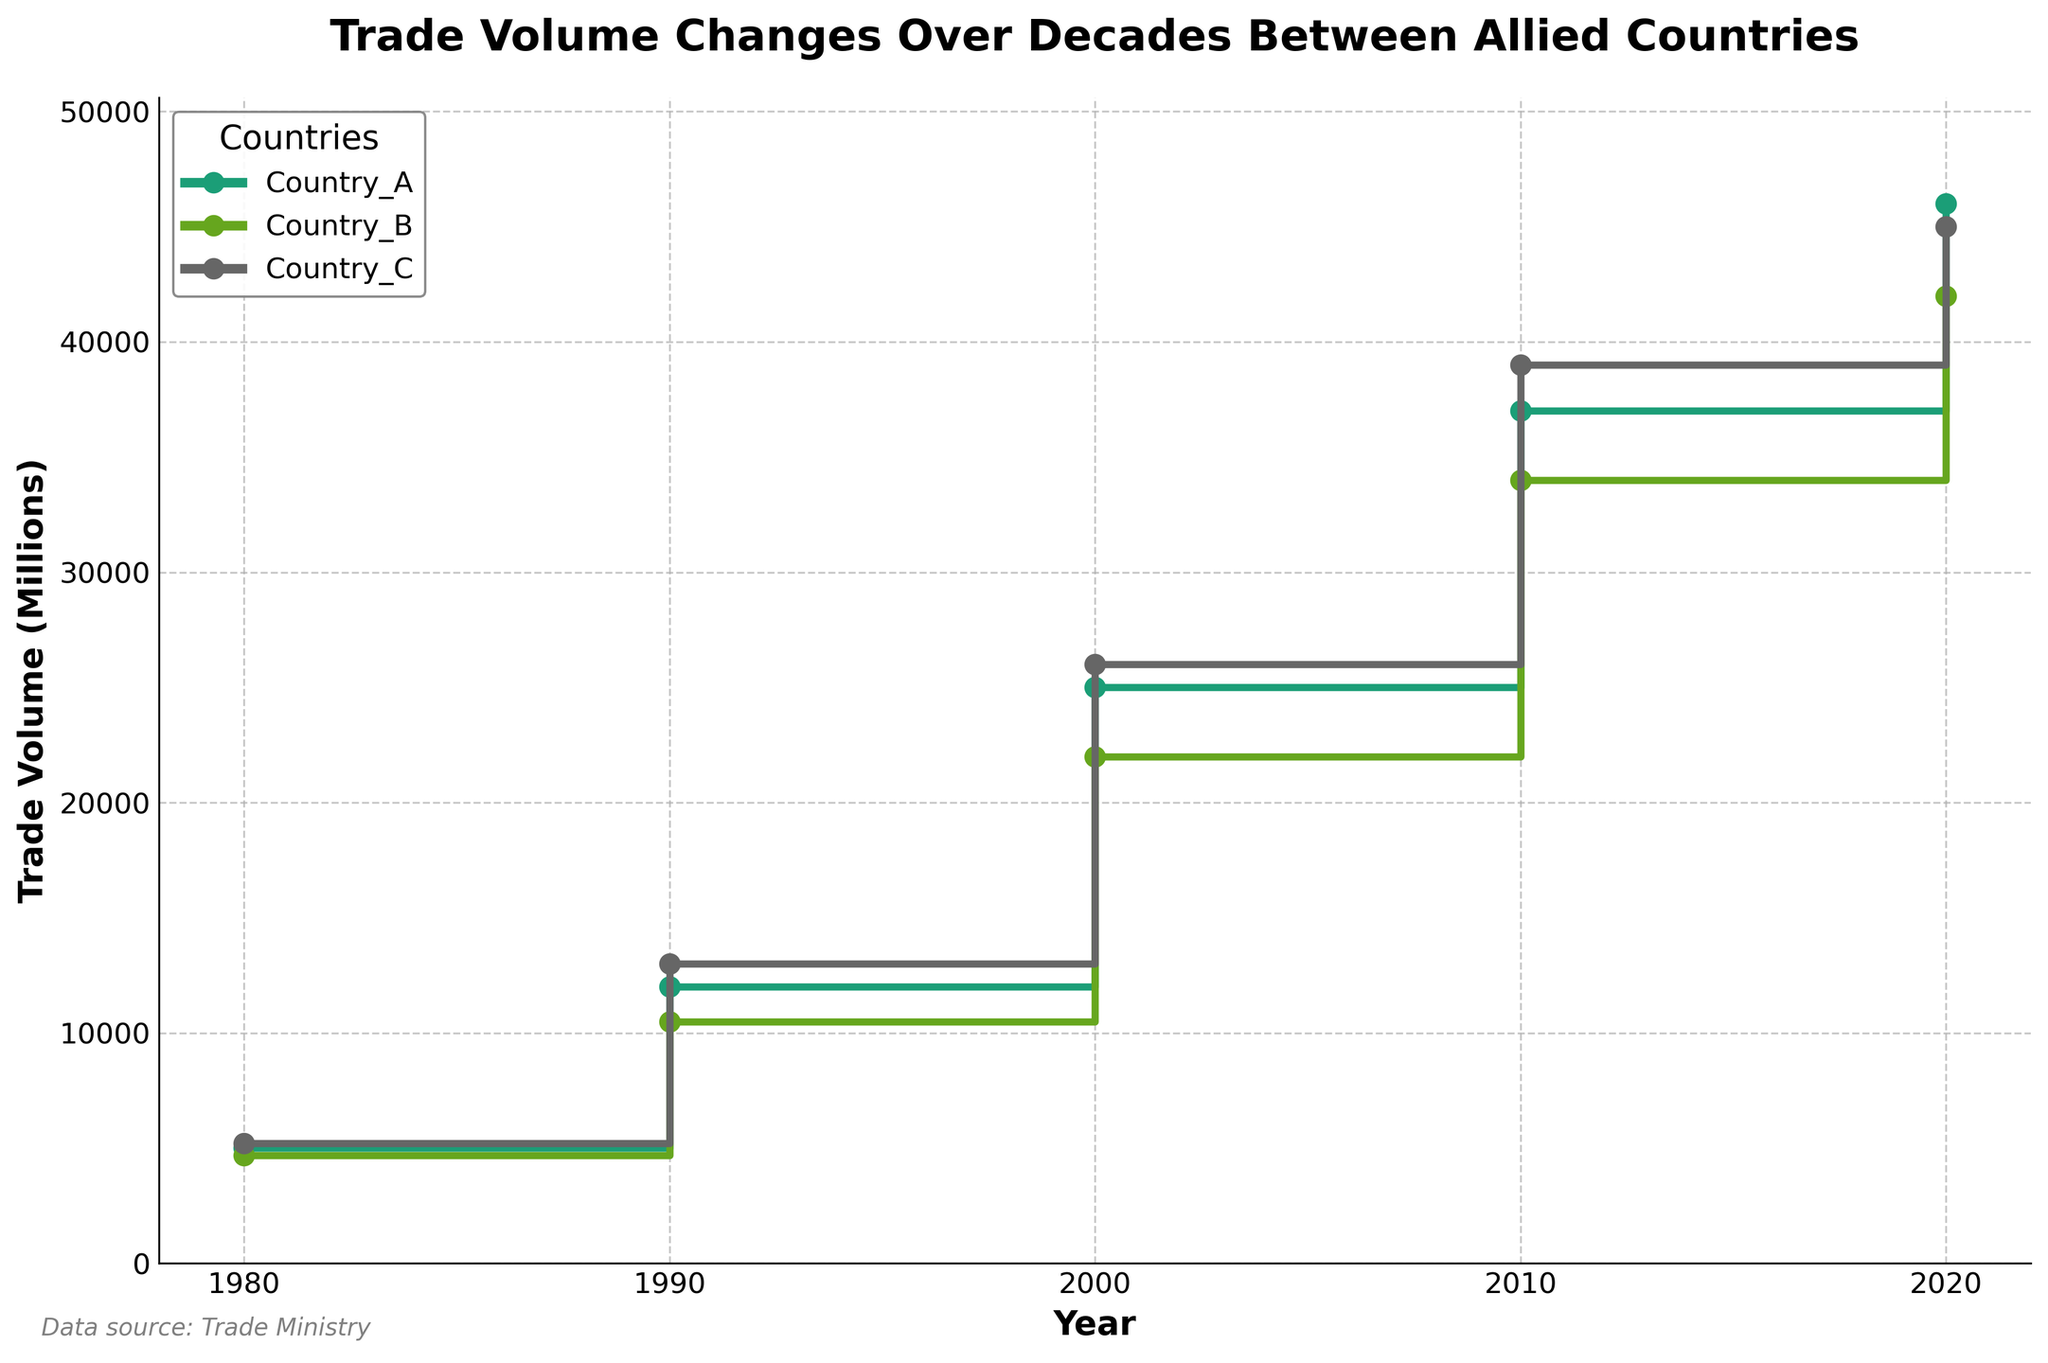What is the title of the figure? The title is the text prominently displayed at the top of the figure. It summarizes the plot's overall theme. In this case, it reads "Trade Volume Changes Over Decades Between Allied Countries."
Answer: Trade Volume Changes Over Decades Between Allied Countries Which country had the highest trade volume in 2020? To determine this, compare the trade volume for each country in the year 2020. Poland has a trade volume of 46,000, Germany 42,000, and France 45,000. The highest trade volume among these is Poland's.
Answer: Poland How many distinct years are shown in the figure? The figure shows data on a horizontal axis with markers for each distinct year. The years labeled are 1980, 1990, 2000, 2010, and 2020. Counting these gives us 5 distinct years.
Answer: 5 Which country showed the largest increase in trade volume from 1980 to 1990? For each country, calculate the difference in trade volume between 1980 and 1990. Poland: 12,000 - 5,000 = 7,000, Germany: 10,500 - 4,700 = 5,800, France: 13,000 - 5,200 = 7,800. France showed the largest increase.
Answer: France What's the average trade volume for Germany across all years? To find the average, sum up Germany's trade volumes for all years and divide by the number of years. (4,700 + 10,500 + 22,000 + 34,000 + 42,000) / 5 = 22,240
Answer: 22,240 What is the difference in trade volume between France and Germany in 2020? Subtract Germany's trade volume from France's in 2020. 45,000 - 42,000 = 3,000
Answer: 3,000 Which year had the highest trade volume for all countries combined? Sum the trade volumes of all countries for each year and compare. The sums are: 1980 (14,900), 1990 (31,500), 2000 (73,000), 2010 (110,000), 2020 (133,000). The year with the highest combined trade volume is 2020.
Answer: 2020 Which country experienced the smallest increase in trade volume from 2010 to 2020? For each country, calculate the increase in trade volume from 2010 to 2020. Poland: 46,000 - 37,000 = 9,000, Germany: 42,000 - 34,000 = 8,000, France: 45,000 - 39,000 = 6,000. France experienced the smallest increase.
Answer: France How many trade volume data points are plotted for each country? Each country's line plot has markers for distinct years on the x-axis, each year corresponding to a data point. Given there are 5 years, each country has 5 data points plotted.
Answer: 5 